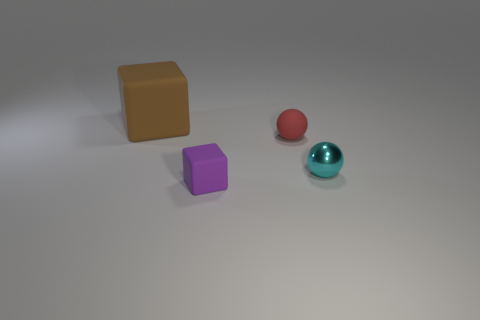What is the material of the thing that is behind the tiny cyan metal thing and to the right of the purple cube?
Give a very brief answer. Rubber. There is a big brown object that is the same material as the small red ball; what shape is it?
Your answer should be very brief. Cube. Are there any other things that have the same shape as the tiny cyan thing?
Offer a very short reply. Yes. Is the material of the block behind the small rubber cube the same as the small cyan object?
Ensure brevity in your answer.  No. There is a ball in front of the red matte sphere; what is its material?
Your answer should be very brief. Metal. There is a matte block that is behind the rubber cube in front of the big brown matte object; what is its size?
Give a very brief answer. Large. How many cyan balls have the same size as the purple rubber thing?
Provide a short and direct response. 1. Does the matte thing that is behind the red object have the same color as the block in front of the matte sphere?
Provide a succinct answer. No. There is a brown rubber block; are there any matte cubes behind it?
Make the answer very short. No. There is a rubber thing that is both to the right of the big object and behind the small purple object; what color is it?
Your answer should be compact. Red. 